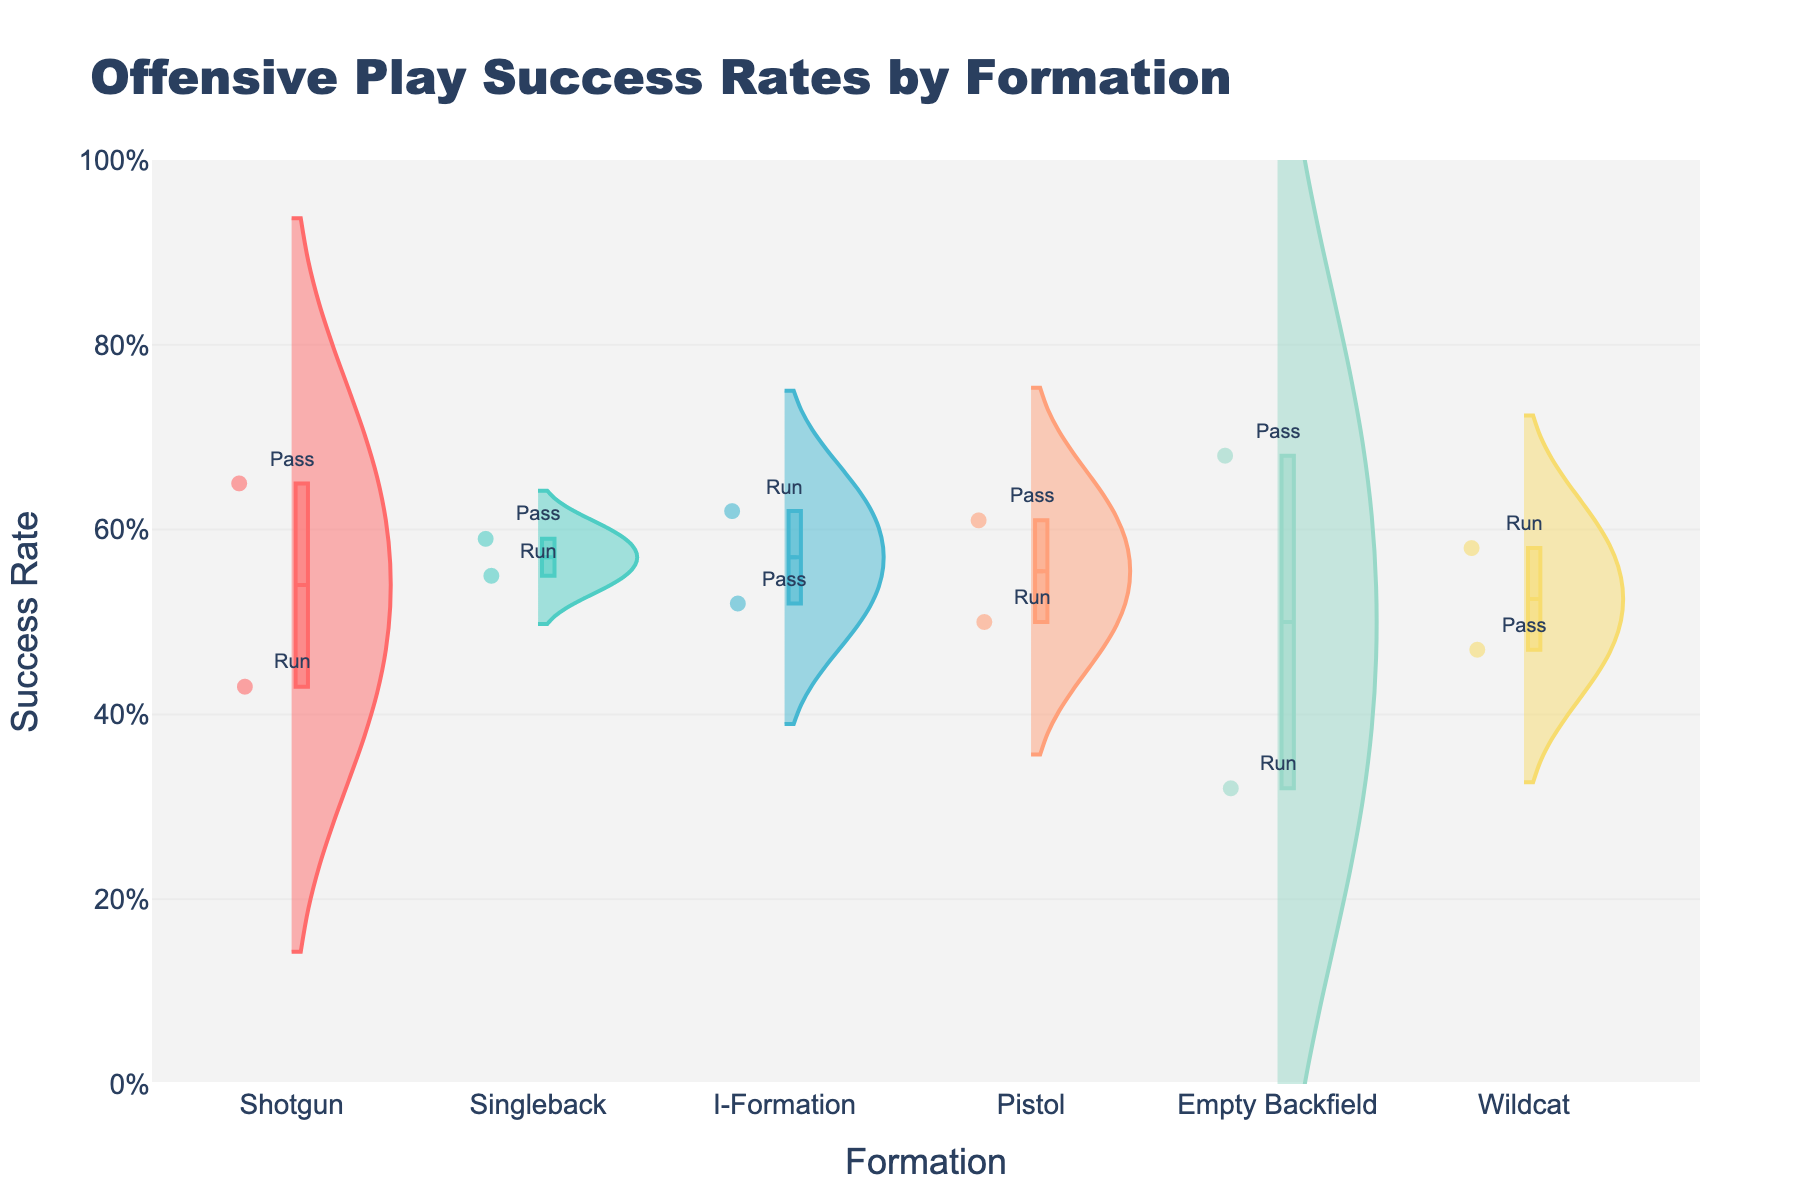What is the title of the plot? The title is usually displayed at the top of the figure. In this case, it states the topic of the plot, which is the success rates of offensive plays by formation
Answer: Offensive Play Success Rates by Formation What is the range of the y-axis? The y-axis range can be determined by looking at the lowest and highest marks on the axis. It also has a specific format for tick values.
Answer: 0% to 100% Which formation has the highest pass success rate? To find this, we need to identify the highest success rate among the formations designated with the 'Pass' label. Look for the highest point labeled 'Pass'.
Answer: Empty Backfield Which formation has the lowest run success rate? To find this, check the success rates of all the formations with the 'Run' label and identify the lowest one.
Answer: Empty Backfield How does the success rate of Passes compare between Shotgun and I-Formation? Look at the position of the points labeled 'Pass' for both Shotgun and I-Formation and compare their values.
Answer: Shotgun has a higher pass success rate For Shotgun formation, is the Pass or Run success rate higher? To determine this, compare the success rates for the 'Pass' and 'Run' labels within the Shotgun formation.
Answer: Pass success rate is higher Which formation has a higher average success rate, Singleback or Wildcat? Calculate the average success rate for each formation by adding their pass and run success rates and dividing by 2, then compare.
Answer: Singleback How many formations have their highest success rate above 60%? Identify the highest success rate for each formation and count how many of these rates are above 60%.
Answer: 3 formations What is the difference between the Run success rates of Singleback and I-Formation? Find the success rates for 'Run' in both Singleback and I-Formation and subtract the smaller one from the larger one.
Answer: 0.07 By how much does the success rate of passing in Pistol differ from running in the same formation? Check the success rates for both 'Pass' and 'Run' in Pistol, then subtract the smaller value from the larger one.
Answer: 0.11 